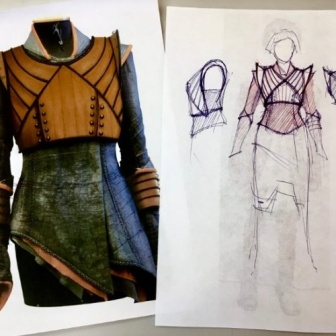How does the texture of the materials used in the dress contribute to its overall appearance? The texture of the materials adds a significant layer of depth to the dress's appearance. The contrast between what appears to be smooth, matte leather and the sheer, flowing fabric of the skirt creates a dynamic visual effect. The rugged texture of the leather components suggests durability and structure, while the softness of the skirt's fabric implies movement and elegance, resulting in a garment that exudes both strength and grace. 